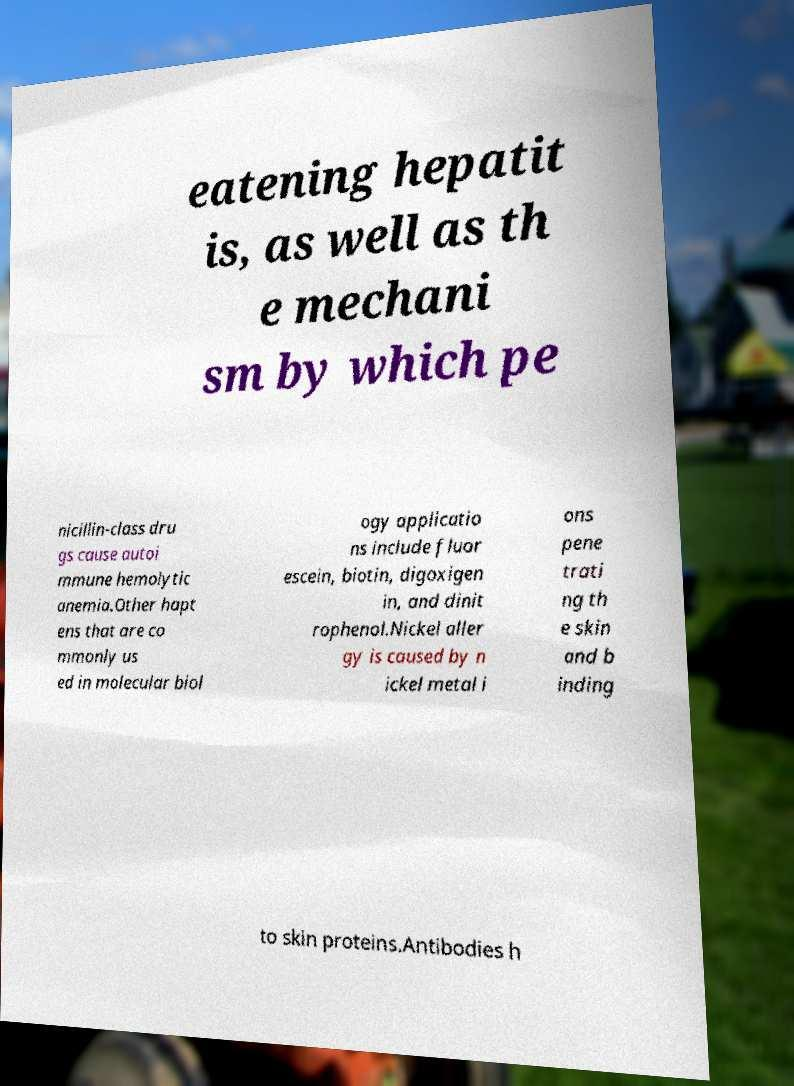There's text embedded in this image that I need extracted. Can you transcribe it verbatim? eatening hepatit is, as well as th e mechani sm by which pe nicillin-class dru gs cause autoi mmune hemolytic anemia.Other hapt ens that are co mmonly us ed in molecular biol ogy applicatio ns include fluor escein, biotin, digoxigen in, and dinit rophenol.Nickel aller gy is caused by n ickel metal i ons pene trati ng th e skin and b inding to skin proteins.Antibodies h 